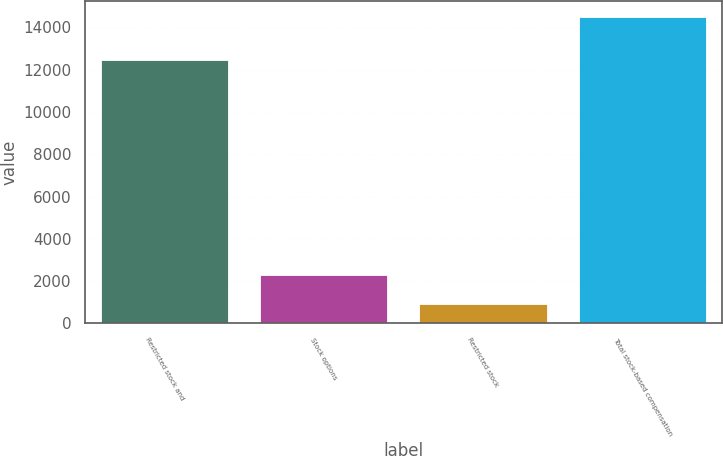Convert chart. <chart><loc_0><loc_0><loc_500><loc_500><bar_chart><fcel>Restricted stock and<fcel>Stock options<fcel>Restricted stock<fcel>Total stock-based compensation<nl><fcel>12459<fcel>2269.2<fcel>909<fcel>14511<nl></chart> 